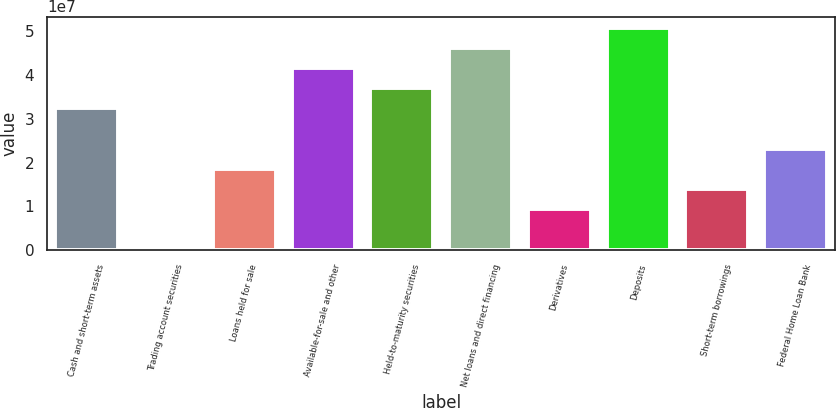<chart> <loc_0><loc_0><loc_500><loc_500><bar_chart><fcel>Cash and short-term assets<fcel>Trading account securities<fcel>Loans held for sale<fcel>Available-for-sale and other<fcel>Held-to-maturity securities<fcel>Net loans and direct financing<fcel>Derivatives<fcel>Deposits<fcel>Short-term borrowings<fcel>Federal Home Loan Bank<nl><fcel>3.24042e+07<fcel>91205<fcel>1.85558e+07<fcel>4.16365e+07<fcel>3.70204e+07<fcel>4.62527e+07<fcel>9.3235e+06<fcel>5.08688e+07<fcel>1.39396e+07<fcel>2.31719e+07<nl></chart> 